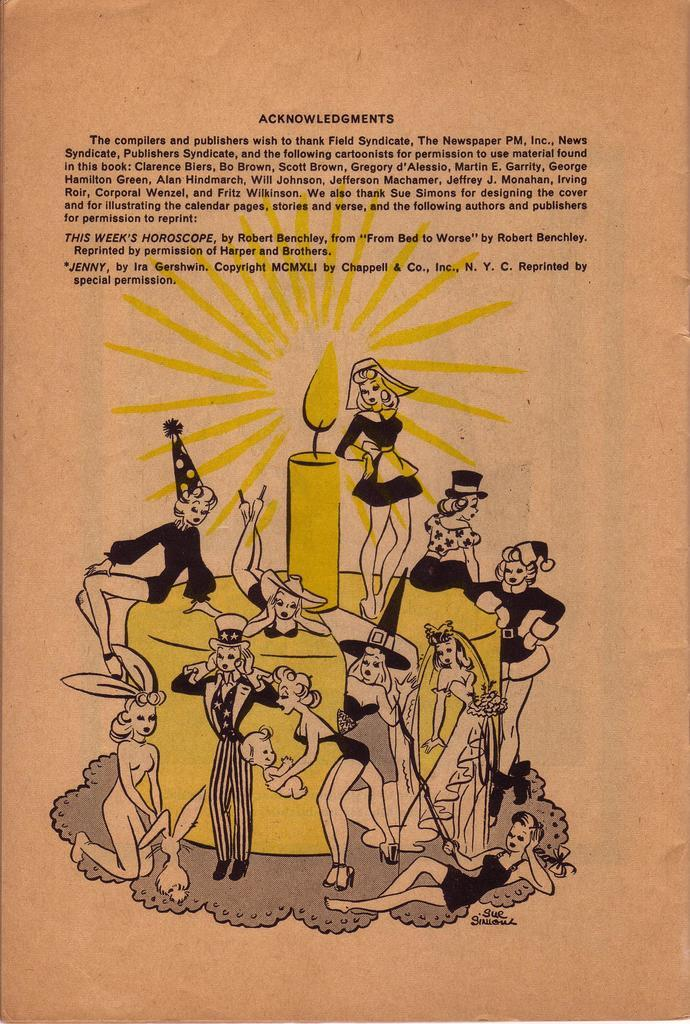What is depicted on the poster in the image? The poster contains a cake with a candle on it. Who is present in the image besides the cake? There are girls standing beside the cake. Can you describe the position of the girls in relation to the cake? There are girls sitting on the cake. How many elbows can be seen gripping the cake in the image? There is no mention of elbows or gripping in the image; the girls are sitting on the cake. 